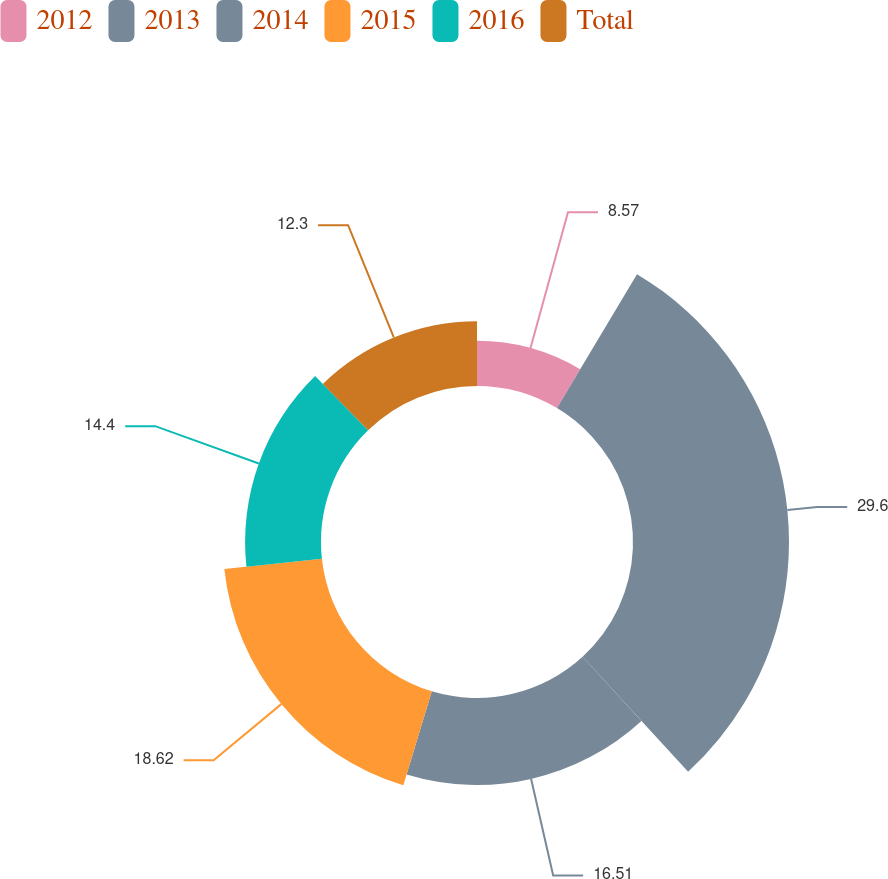Convert chart to OTSL. <chart><loc_0><loc_0><loc_500><loc_500><pie_chart><fcel>2012<fcel>2013<fcel>2014<fcel>2015<fcel>2016<fcel>Total<nl><fcel>8.57%<fcel>29.6%<fcel>16.51%<fcel>18.62%<fcel>14.4%<fcel>12.3%<nl></chart> 